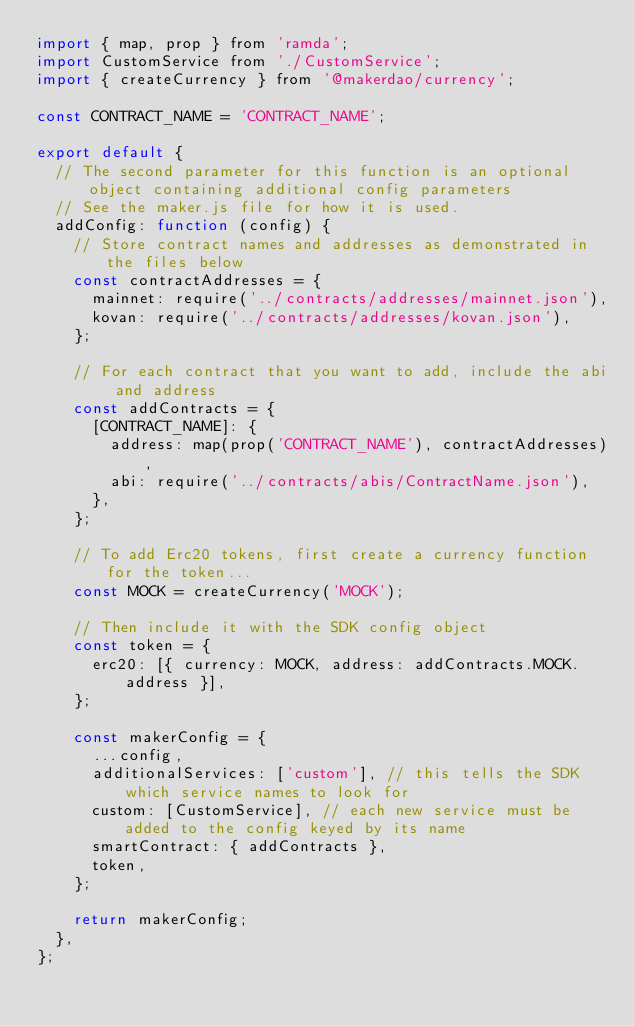Convert code to text. <code><loc_0><loc_0><loc_500><loc_500><_JavaScript_>import { map, prop } from 'ramda';
import CustomService from './CustomService';
import { createCurrency } from '@makerdao/currency';

const CONTRACT_NAME = 'CONTRACT_NAME';

export default {
  // The second parameter for this function is an optional object containing additional config parameters
  // See the maker.js file for how it is used.
  addConfig: function (config) {
    // Store contract names and addresses as demonstrated in the files below
    const contractAddresses = {
      mainnet: require('../contracts/addresses/mainnet.json'),
      kovan: require('../contracts/addresses/kovan.json'),
    };

    // For each contract that you want to add, include the abi and address
    const addContracts = {
      [CONTRACT_NAME]: {
        address: map(prop('CONTRACT_NAME'), contractAddresses),
        abi: require('../contracts/abis/ContractName.json'),
      },
    };

    // To add Erc20 tokens, first create a currency function for the token...
    const MOCK = createCurrency('MOCK');

    // Then include it with the SDK config object
    const token = {
      erc20: [{ currency: MOCK, address: addContracts.MOCK.address }],
    };

    const makerConfig = {
      ...config,
      additionalServices: ['custom'], // this tells the SDK which service names to look for
      custom: [CustomService], // each new service must be added to the config keyed by its name
      smartContract: { addContracts },
      token,
    };

    return makerConfig;
  },
};
</code> 